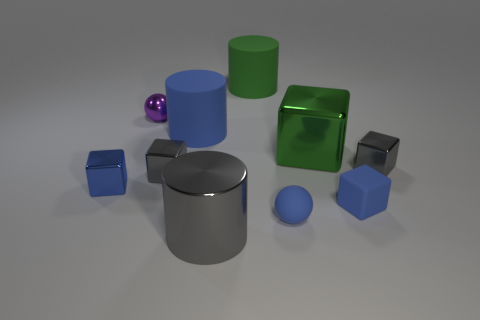Subtract 1 blocks. How many blocks are left? 4 Subtract all cyan cubes. Subtract all yellow balls. How many cubes are left? 5 Subtract all cylinders. How many objects are left? 7 Subtract all big blue rubber things. Subtract all big blue rubber cylinders. How many objects are left? 8 Add 2 metallic objects. How many metallic objects are left? 8 Add 2 rubber objects. How many rubber objects exist? 6 Subtract 1 green cubes. How many objects are left? 9 